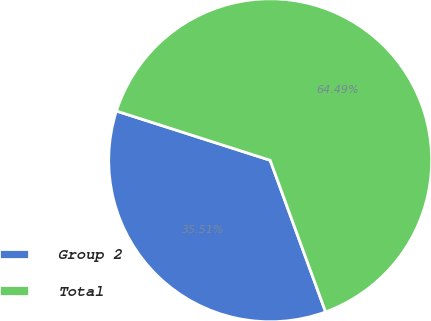<chart> <loc_0><loc_0><loc_500><loc_500><pie_chart><fcel>Group 2<fcel>Total<nl><fcel>35.51%<fcel>64.49%<nl></chart> 